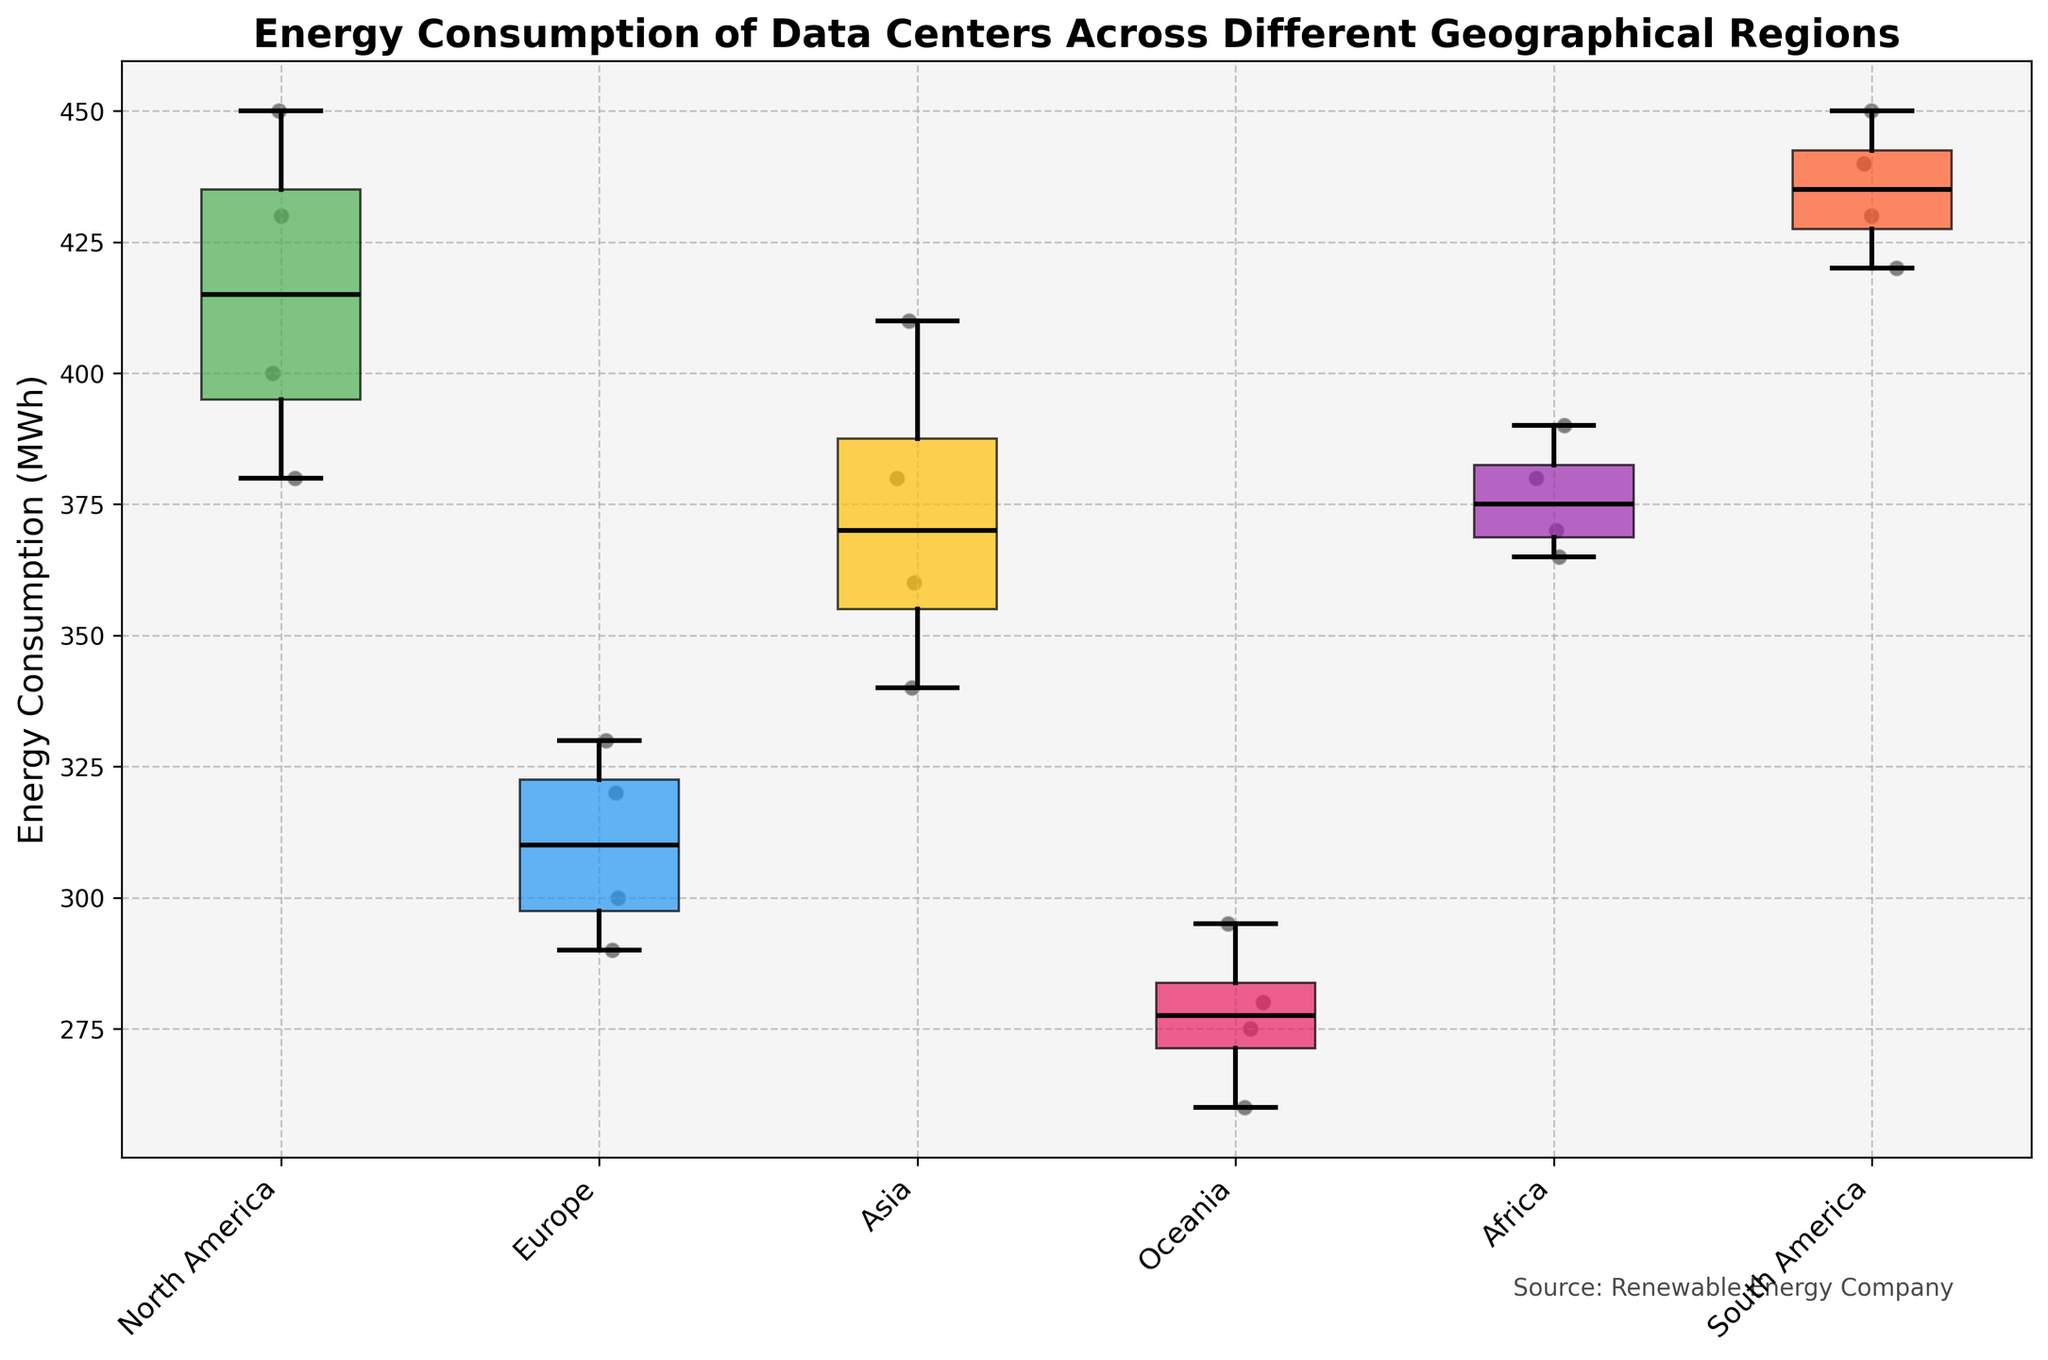What is the title of the plot? The title of the plot is located at the top, usually in bold font. It summarizes what the plot is about.
Answer: Energy Consumption of Data Centers Across Different Geographical Regions Which region has the lowest median energy consumption? By looking at the horizontal line in the box closest to the bottom of the plot, this line represents the median energy consumption.
Answer: Oceania How many data centers are represented in the Asia region? To find the number of data points in the Asia region, observe the scatter points within the corresponding box plot.
Answer: 4 Which region has the highest energy consumption outlier? Outliers in a box plot are typically represented by points outside the whiskers. Look for the highest point outside the whiskers.
Answer: South America What is the range of energy consumption for the data centers in Europe? The range is calculated by subtracting the minimum value (bottom of the whisker) from the maximum value (top of the whisker) within the Europe region.
Answer: 40 MWh (330 MWh - 290 MWh) Which region shows the widest variability in energy consumption? Variability is indicated by the height of the box plus the length of the whiskers. The region with the tallest total plot has the widest variability.
Answer: North America Which region has the smallest interquartile range (IQR) of energy consumption? The IQR is the difference between the third quartile (top of the box) and the first quartile (bottom of the box). The region with the smallest box height has the smallest IQR.
Answer: Oceania How does the median energy consumption in Africa compare to Europe? Compare the midlines (medians) within the boxes for both Africa and Europe. The region with a higher median will have its midline higher up the y-axis.
Answer: Africa's median is higher than Europe's What can be inferred about the energy efficiency of data centers in different regions? Regions with lower median energy consumption and less variability typically indicate better energy efficiency.
Answer: Data centers in Oceania and Europe are more energy-efficient Which two regions have the closest median energy consumption? Observe the median lines within the boxes and compare their positions on the y-axis. The regions with the lines closest to one another have the closest median.
Answer: South America and North America 